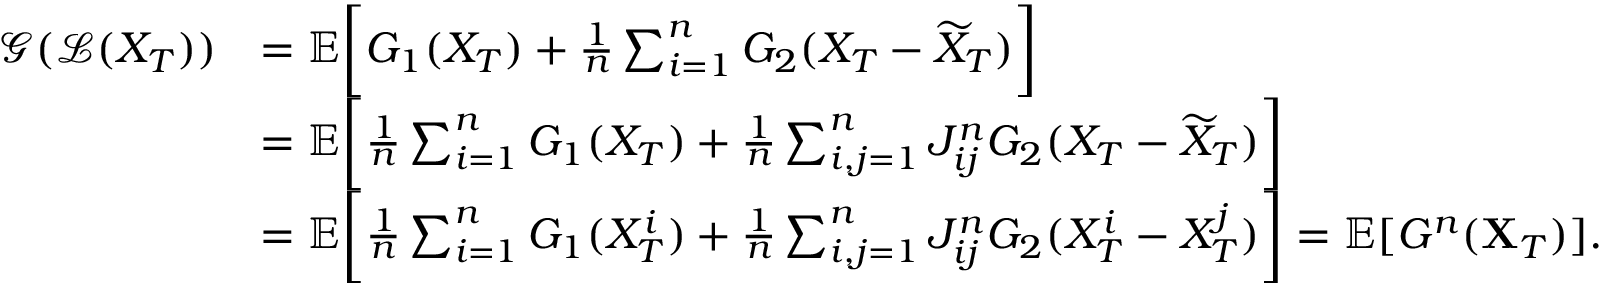Convert formula to latex. <formula><loc_0><loc_0><loc_500><loc_500>\begin{array} { r l } { \mathcal { G } ( \mathcal { L } ( X _ { T } ) ) } & { = { \mathbb { E } } \left [ G _ { 1 } ( X _ { T } ) + \frac { 1 } { n } \sum _ { i = 1 } ^ { n } G _ { 2 } ( X _ { T } - \widetilde { X } _ { T } ) \right ] } \\ & { = { \mathbb { E } } \left [ \frac { 1 } { n } \sum _ { i = 1 } ^ { n } G _ { 1 } ( X _ { T } ) + \frac { 1 } { n } \sum _ { i , j = 1 } ^ { n } J _ { i j } ^ { n } G _ { 2 } ( X _ { T } - \widetilde { X } _ { T } ) \right ] } \\ & { = { \mathbb { E } } \left [ \frac { 1 } { n } \sum _ { i = 1 } ^ { n } G _ { 1 } ( X _ { T } ^ { i } ) + \frac { 1 } { n } \sum _ { i , j = 1 } ^ { n } J _ { i j } ^ { n } G _ { 2 } ( X _ { T } ^ { i } - X _ { T } ^ { j } ) \right ] = { \mathbb { E } } [ G ^ { n } ( X _ { T } ) ] . } \end{array}</formula> 